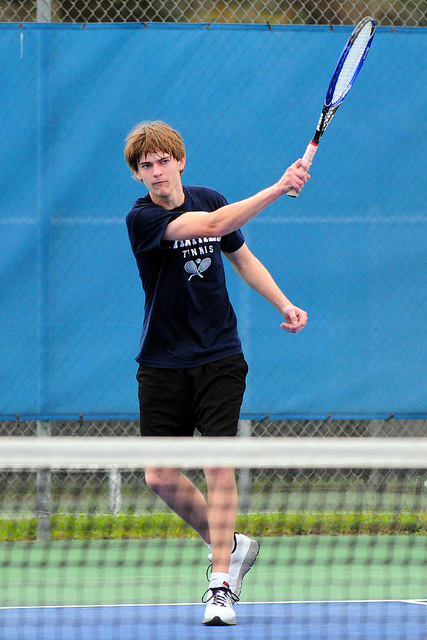Identify the text displayed in this image. TNNIS 